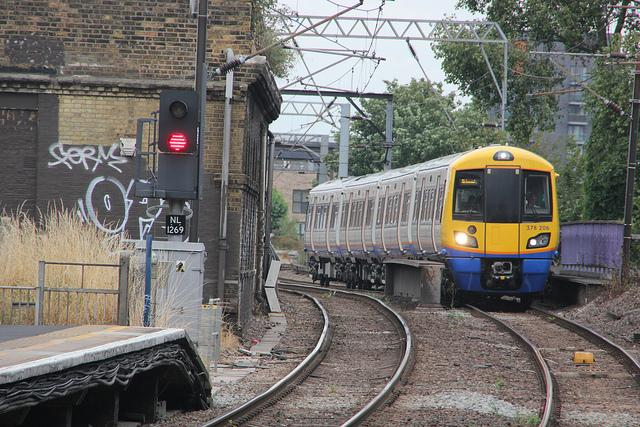This train is moved by what energy? electricity 